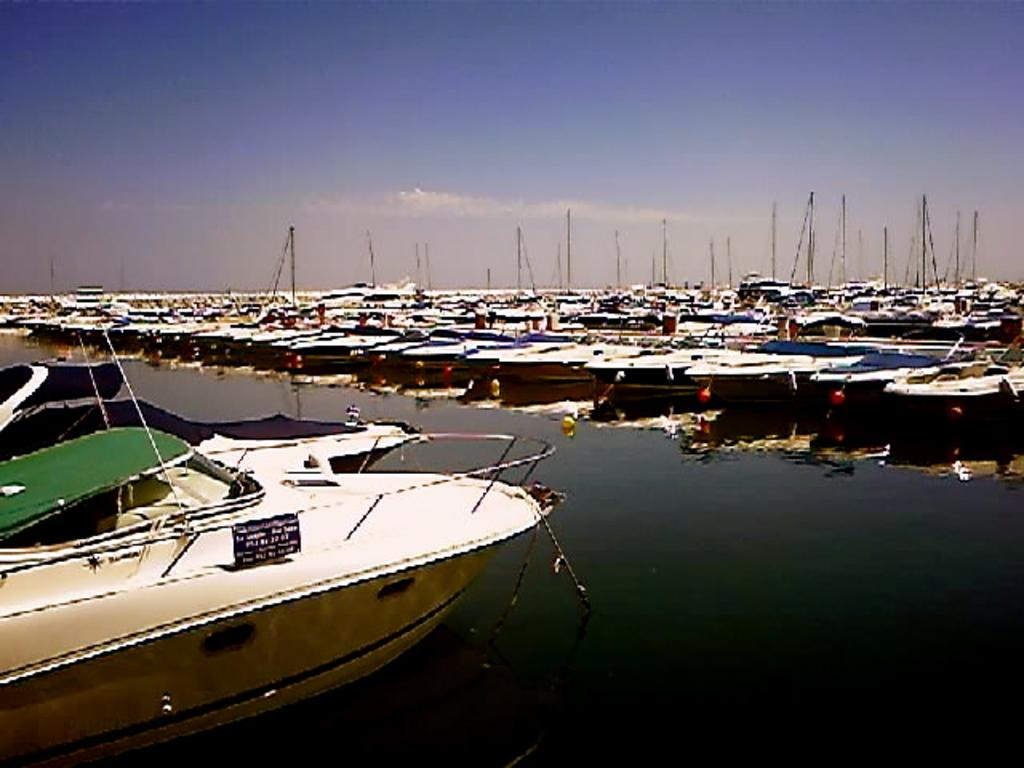What is located in the water body in the image? There is a boat in the water body in the image. How many boats with poles can be seen in the image? There is a group of boats with poles in the image. What is the position of the poles in relation to the boats? The poles are placed aside in the image. What is visible in the background of the image? The sky is visible in the image. What is the weather condition suggested by the appearance of the sky? The sky appears cloudy, suggesting a potentially overcast or rainy weather condition. What type of cub can be seen playing with the boats in the image? There is no cub present in the image; it features a group of boats with poles in a water body. What kind of meal is being prepared on the boats in the image? There is no indication of any meal preparation or cooking activity on the boats in the image. 